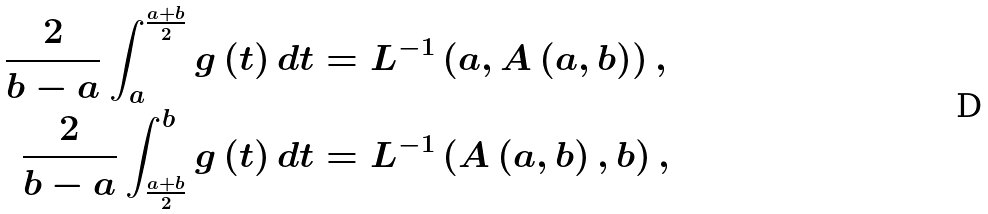Convert formula to latex. <formula><loc_0><loc_0><loc_500><loc_500>\frac { 2 } { b - a } \int _ { a } ^ { \frac { a + b } { 2 } } g \left ( t \right ) d t & = L ^ { - 1 } \left ( a , A \left ( a , b \right ) \right ) , \\ \frac { 2 } { b - a } \int _ { \frac { a + b } { 2 } } ^ { b } g \left ( t \right ) d t & = L ^ { - 1 } \left ( A \left ( a , b \right ) , b \right ) ,</formula> 